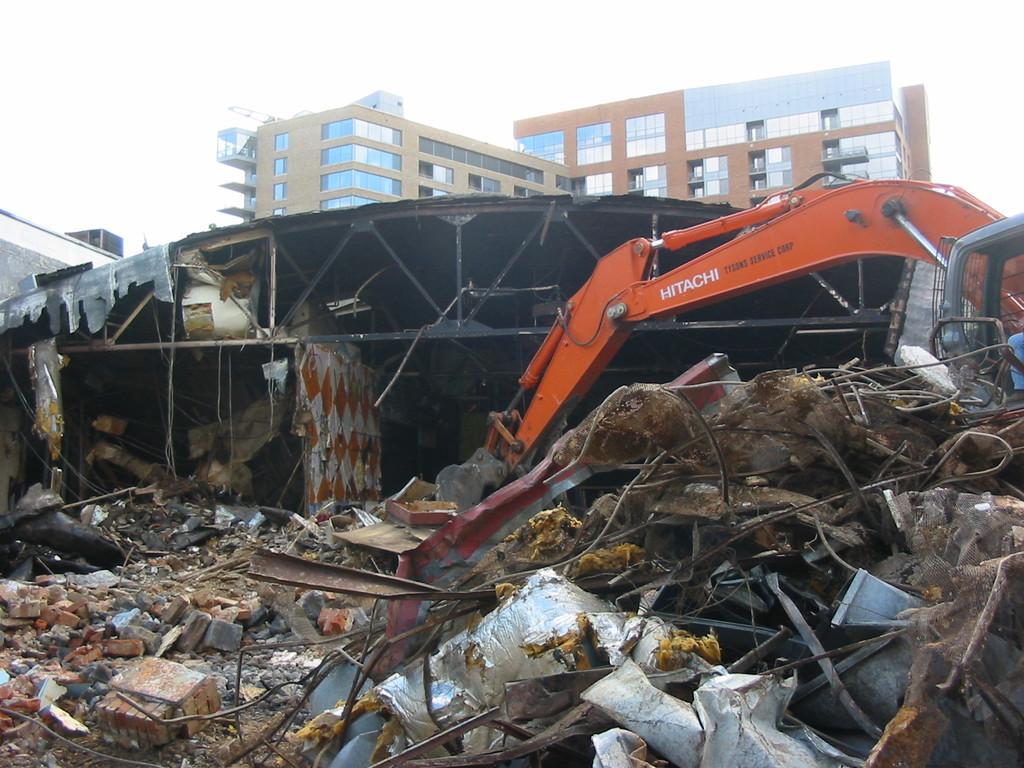Please provide a concise description of this image. In this image we can see the scrap on the ground. We can also see some stones, wires, an excavator and a roof. On the backside we can see some buildings with windows and the sky. 